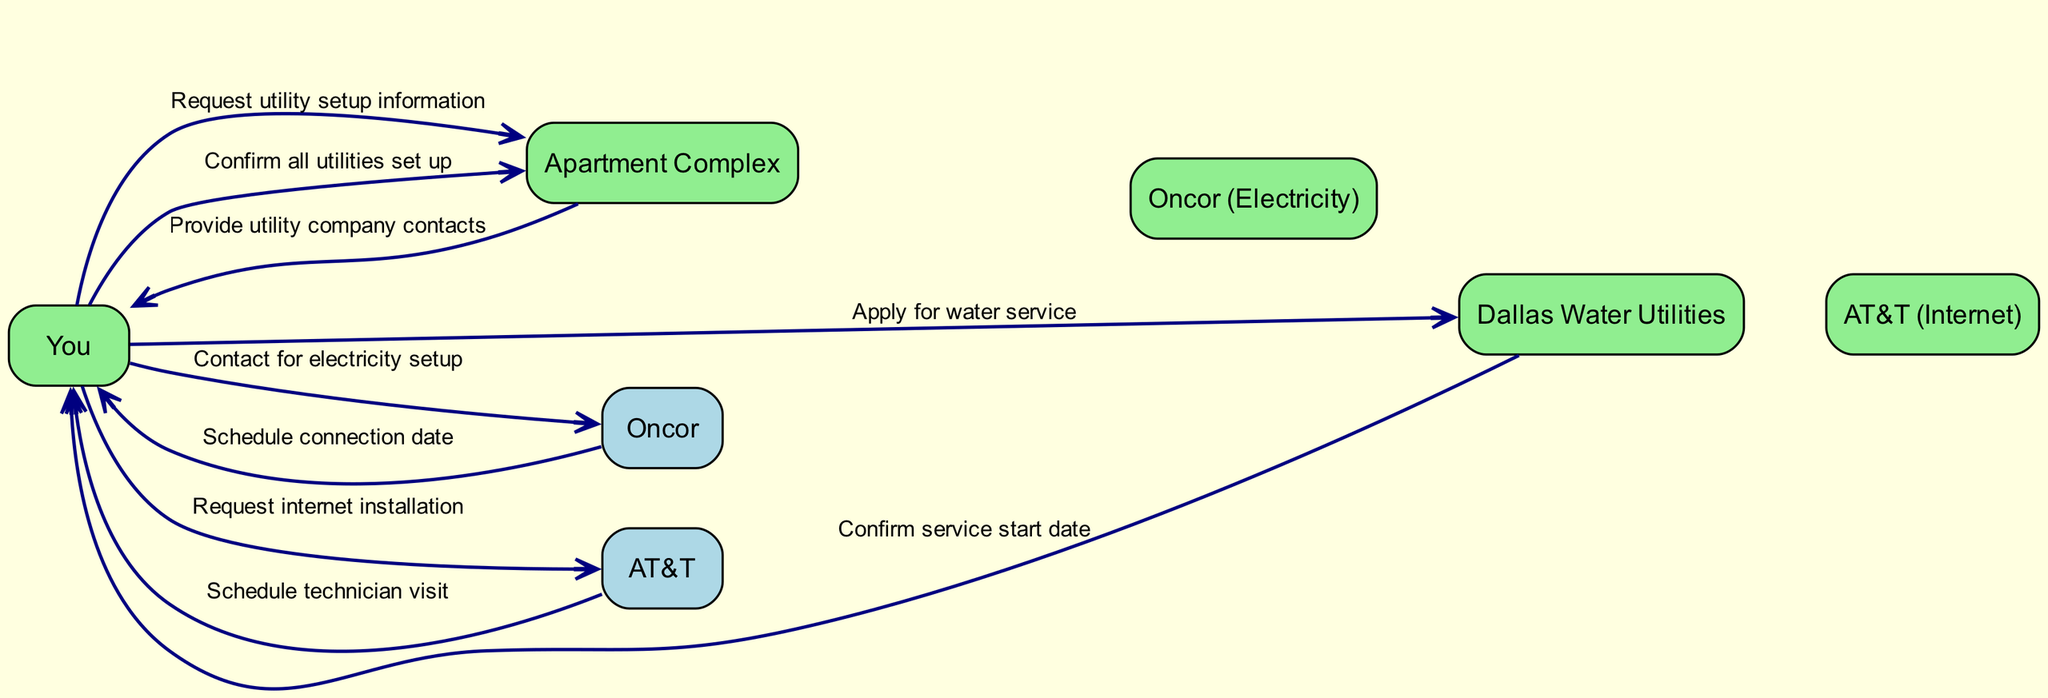What are the actors in the diagram? The actors are listed in the diagram and include "You", "Apartment Complex", "Oncor (Electricity)", "Dallas Water Utilities", and "AT&T (Internet)".
Answer: You, Apartment Complex, Oncor (Electricity), Dallas Water Utilities, AT&T (Internet) How many steps are there in the sequence? By counting the entries in the sequence list of the diagram, there are 8 distinct steps described.
Answer: 8 What is the first action taken by you in the sequence? The first action taken is "Request utility setup information" directed to the "Apartment Complex".
Answer: Request utility setup information Who confirms the service start date for water? The confirmation of the service start date is given by "Dallas Water Utilities" after you apply for water service.
Answer: Dallas Water Utilities What is the last action performed in the sequence? The last action is "Confirm all utilities set up" directed to the "Apartment Complex" after setting up the utilities.
Answer: Confirm all utilities set up Which utility service is contacted after electricity? After contacting for electricity, the next service that you reach out to is "Dallas Water Utilities" to apply for water service.
Answer: Dallas Water Utilities What action follows the scheduling of the technician visit? After the scheduling of the technician visit by "AT&T", the next action taken is to confirm the setup of all utilities with the "Apartment Complex".
Answer: Confirm all utilities set up How many utility companies are involved in the process? There are three utility companies involved in the process: "Oncor (Electricity)", "Dallas Water Utilities", and "AT&T (Internet)".
Answer: 3 